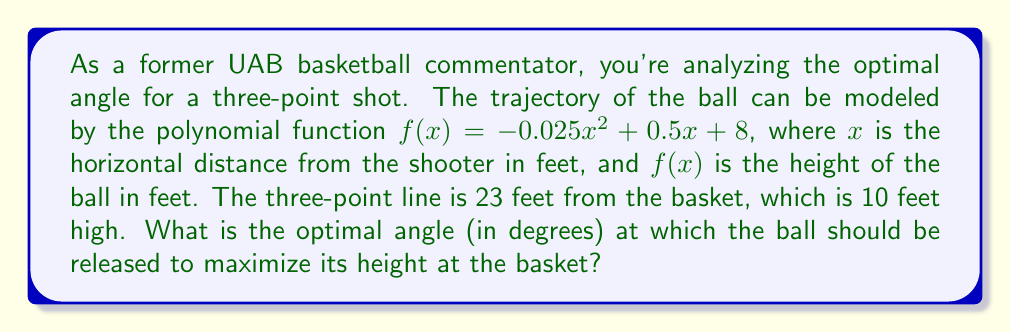Provide a solution to this math problem. Let's approach this step-by-step:

1) First, we need to find the height of the ball at the basket. We know that the basket is 23 feet away from the shooter horizontally. So, we can substitute $x = 23$ into our function:

   $f(23) = -0.025(23)^2 + 0.5(23) + 8 = -13.225 + 11.5 + 8 = 6.275$ feet

2) Now, to find the optimal angle, we need to calculate the slope of the trajectory at $x = 23$. This slope is the tangent of the release angle. We can find this by taking the derivative of $f(x)$ and evaluating it at $x = 23$:

   $f'(x) = -0.05x + 0.5$
   $f'(23) = -0.05(23) + 0.5 = -0.65$

3) The tangent of the angle is the negative reciprocal of this slope (because we're looking at the angle from the horizontal, not the angle of the trajectory). So:

   $\tan(\theta) = -\frac{1}{-0.65} = 1.5385$

4) To get the angle in degrees, we need to take the arctangent and convert to degrees:

   $\theta = \arctan(1.5385) \approx 0.9948$ radians

5) Convert to degrees:

   $\theta \approx 0.9948 \times \frac{180}{\pi} \approx 57.0°$
Answer: 57.0° 